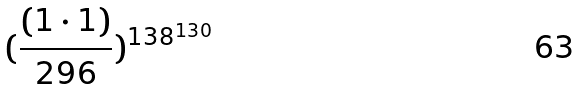Convert formula to latex. <formula><loc_0><loc_0><loc_500><loc_500>( \frac { ( 1 \cdot 1 ) } { 2 9 6 } ) ^ { 1 3 8 ^ { 1 3 0 } }</formula> 